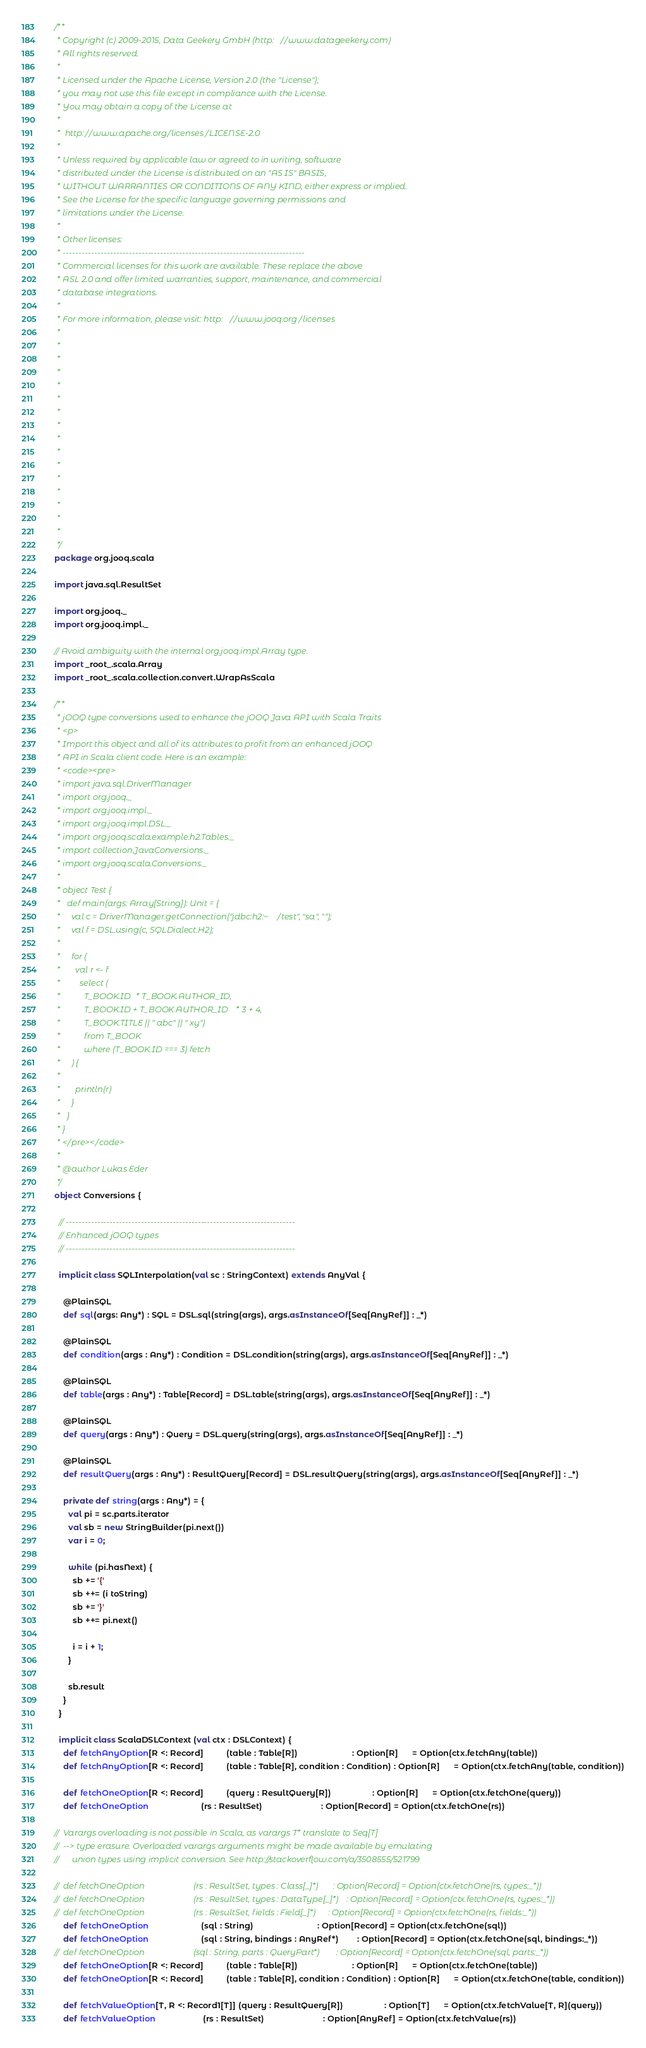Convert code to text. <code><loc_0><loc_0><loc_500><loc_500><_Scala_>/**
 * Copyright (c) 2009-2015, Data Geekery GmbH (http://www.datageekery.com)
 * All rights reserved.
 *
 * Licensed under the Apache License, Version 2.0 (the "License");
 * you may not use this file except in compliance with the License.
 * You may obtain a copy of the License at
 *
 *  http://www.apache.org/licenses/LICENSE-2.0
 *
 * Unless required by applicable law or agreed to in writing, software
 * distributed under the License is distributed on an "AS IS" BASIS,
 * WITHOUT WARRANTIES OR CONDITIONS OF ANY KIND, either express or implied.
 * See the License for the specific language governing permissions and
 * limitations under the License.
 *
 * Other licenses:
 * -----------------------------------------------------------------------------
 * Commercial licenses for this work are available. These replace the above
 * ASL 2.0 and offer limited warranties, support, maintenance, and commercial
 * database integrations.
 *
 * For more information, please visit: http://www.jooq.org/licenses
 *
 *
 *
 *
 *
 *
 *
 *
 *
 *
 *
 *
 *
 *
 *
 *
 */
package org.jooq.scala

import java.sql.ResultSet

import org.jooq._
import org.jooq.impl._

// Avoid ambiguity with the internal org.jooq.impl.Array type.
import _root_.scala.Array
import _root_.scala.collection.convert.WrapAsScala

/**
 * jOOQ type conversions used to enhance the jOOQ Java API with Scala Traits
 * <p>
 * Import this object and all of its attributes to profit from an enhanced jOOQ
 * API in Scala client code. Here is an example:
 * <code><pre>
 * import java.sql.DriverManager
 * import org.jooq._
 * import org.jooq.impl._
 * import org.jooq.impl.DSL._
 * import org.jooq.scala.example.h2.Tables._
 * import collection.JavaConversions._
 * import org.jooq.scala.Conversions._
 *
 * object Test {
 *   def main(args: Array[String]): Unit = {
 *     val c = DriverManager.getConnection("jdbc:h2:~/test", "sa", "");
 *     val f = DSL.using(c, SQLDialect.H2);
 *
 *     for (
 *       val r <- f
 *         select (
 *           T_BOOK.ID * T_BOOK.AUTHOR_ID,
 *           T_BOOK.ID + T_BOOK.AUTHOR_ID * 3 + 4,
 *           T_BOOK.TITLE || " abc" || " xy")
 *           from T_BOOK
 *           where (T_BOOK.ID === 3) fetch
 *     ) {
 *
 *       println(r)
 *     }
 *   }
 * }
 * </pre></code>
 *
 * @author Lukas Eder
 */
object Conversions {

  // -------------------------------------------------------------------------
  // Enhanced jOOQ types
  // -------------------------------------------------------------------------

  implicit class SQLInterpolation(val sc : StringContext) extends AnyVal {

    @PlainSQL
    def sql(args: Any*) : SQL = DSL.sql(string(args), args.asInstanceOf[Seq[AnyRef]] : _*)

    @PlainSQL
    def condition(args : Any*) : Condition = DSL.condition(string(args), args.asInstanceOf[Seq[AnyRef]] : _*)

    @PlainSQL
    def table(args : Any*) : Table[Record] = DSL.table(string(args), args.asInstanceOf[Seq[AnyRef]] : _*)

    @PlainSQL
    def query(args : Any*) : Query = DSL.query(string(args), args.asInstanceOf[Seq[AnyRef]] : _*)

    @PlainSQL
    def resultQuery(args : Any*) : ResultQuery[Record] = DSL.resultQuery(string(args), args.asInstanceOf[Seq[AnyRef]] : _*)

    private def string(args : Any*) = {
      val pi = sc.parts.iterator
      val sb = new StringBuilder(pi.next())
      var i = 0;

      while (pi.hasNext) {
        sb += '{'
        sb ++= (i toString)
        sb += '}'
        sb ++= pi.next()

        i = i + 1;
      }

      sb.result
    }
  }

  implicit class ScalaDSLContext (val ctx : DSLContext) {
    def fetchAnyOption[R <: Record]          (table : Table[R])                        : Option[R]      = Option(ctx.fetchAny(table))
    def fetchAnyOption[R <: Record]          (table : Table[R], condition : Condition) : Option[R]      = Option(ctx.fetchAny(table, condition))
                                             
    def fetchOneOption[R <: Record]          (query : ResultQuery[R])                  : Option[R]      = Option(ctx.fetchOne(query))
    def fetchOneOption                       (rs : ResultSet)                          : Option[Record] = Option(ctx.fetchOne(rs))

//  Varargs overloading is not possible in Scala, as varargs T* translate to Seq[T]
//  --> type erasure. Overloaded varargs arguments might be made available by emulating
//      union types using implicit conversion. See http://stackoverflow.com/a/3508555/521799

//  def fetchOneOption                       (rs : ResultSet, types : Class[_]*)       : Option[Record] = Option(ctx.fetchOne(rs, types:_*))
//  def fetchOneOption                       (rs : ResultSet, types : DataType[_]*)    : Option[Record] = Option(ctx.fetchOne(rs, types:_*))
//  def fetchOneOption                       (rs : ResultSet, fields : Field[_]*)      : Option[Record] = Option(ctx.fetchOne(rs, fields:_*))
    def fetchOneOption                       (sql : String)                            : Option[Record] = Option(ctx.fetchOne(sql))
    def fetchOneOption                       (sql : String, bindings : AnyRef*)        : Option[Record] = Option(ctx.fetchOne(sql, bindings:_*))
//  def fetchOneOption                       (sql : String, parts : QueryPart*)        : Option[Record] = Option(ctx.fetchOne(sql, parts:_*))
    def fetchOneOption[R <: Record]          (table : Table[R])                        : Option[R]      = Option(ctx.fetchOne(table))
    def fetchOneOption[R <: Record]          (table : Table[R], condition : Condition) : Option[R]      = Option(ctx.fetchOne(table, condition))

    def fetchValueOption[T, R <: Record1[T]] (query : ResultQuery[R])                  : Option[T]      = Option(ctx.fetchValue[T, R](query))
    def fetchValueOption                     (rs : ResultSet)                          : Option[AnyRef] = Option(ctx.fetchValue(rs))</code> 